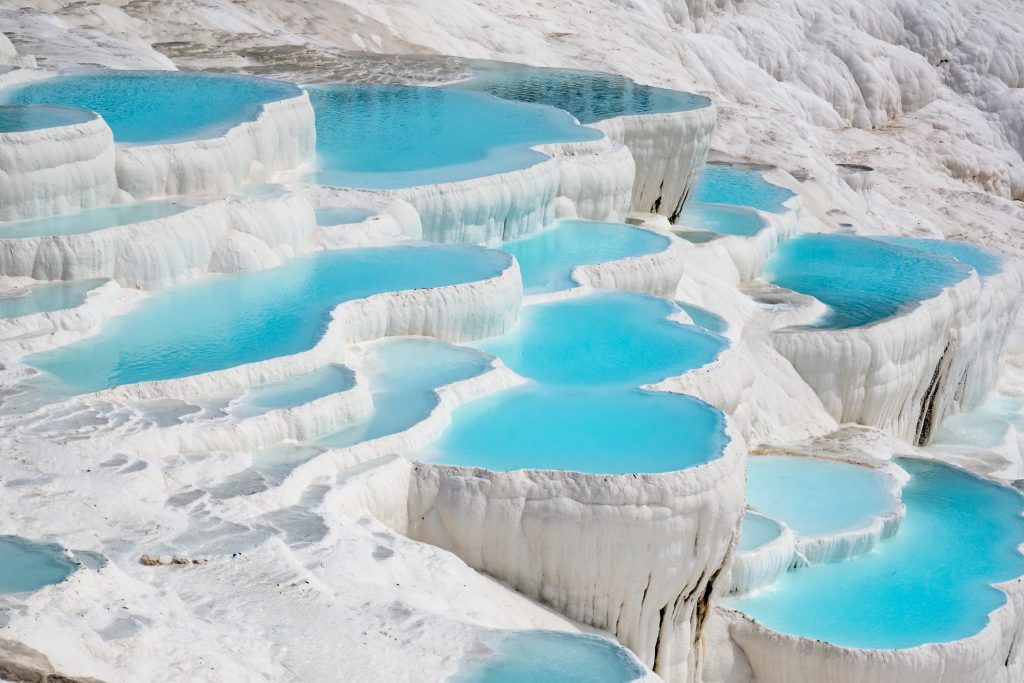What can you tell me about the significance of this location? Pamukkale is a UNESCO World Heritage site known for its unique geological formations. The name Pamukkale translates to 'Cotton Castle' in Turkish, a fitting moniker given the visual resemblance of the travertine terraces to cascading cotton. These terraces have formed over thousands of years due to the deposition of calcium carbonate from the hot springs that flow through the area. Beyond its natural beauty, Pamukkale has historical significance as well. The ancient Greco-Roman city of Hierapolis was built atop the white 'castle,' and its ruins, including a theater and necropolis, add an archaeological dimension to the site. Visitors can explore the terraces, bathe in the thermal waters, and visit the ruins, making it a multifaceted attraction blending natural wonder with historical intrigue. 